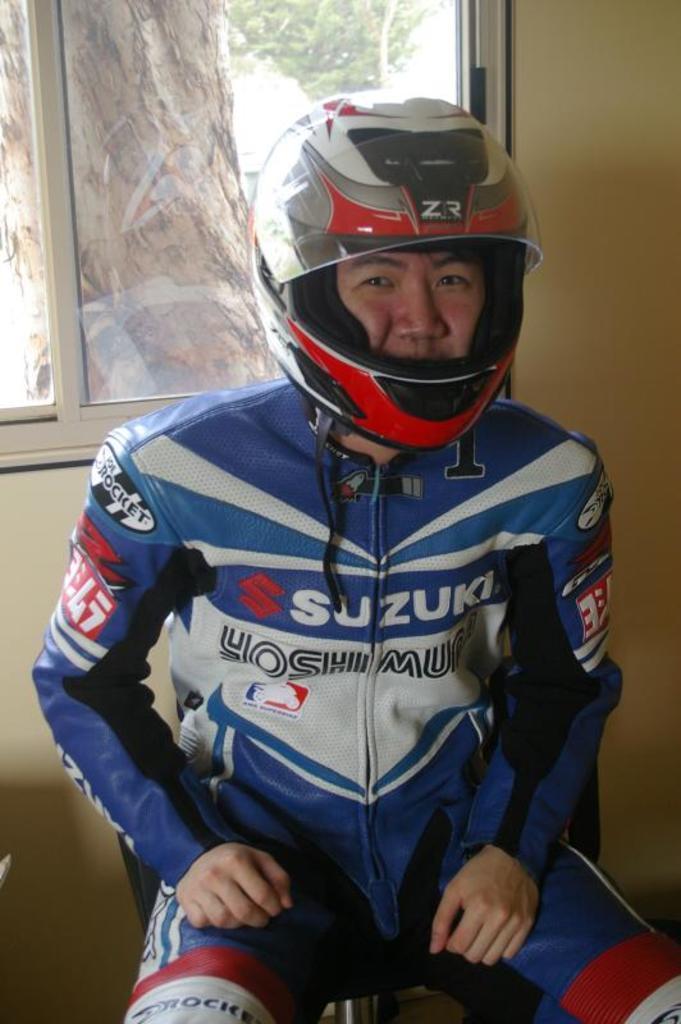Please provide a concise description of this image. In this image, we can see a person is sitting on the chair and wearing a helmet. Background we can see a wall and glass window. Through the glass we can see the outside view. Here we can see a tree trunk and tree. 